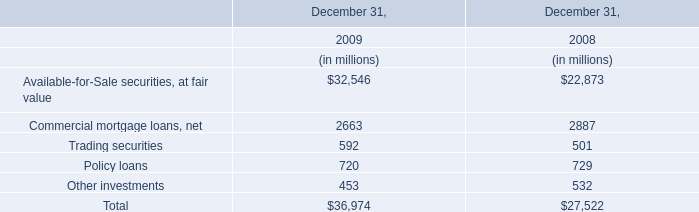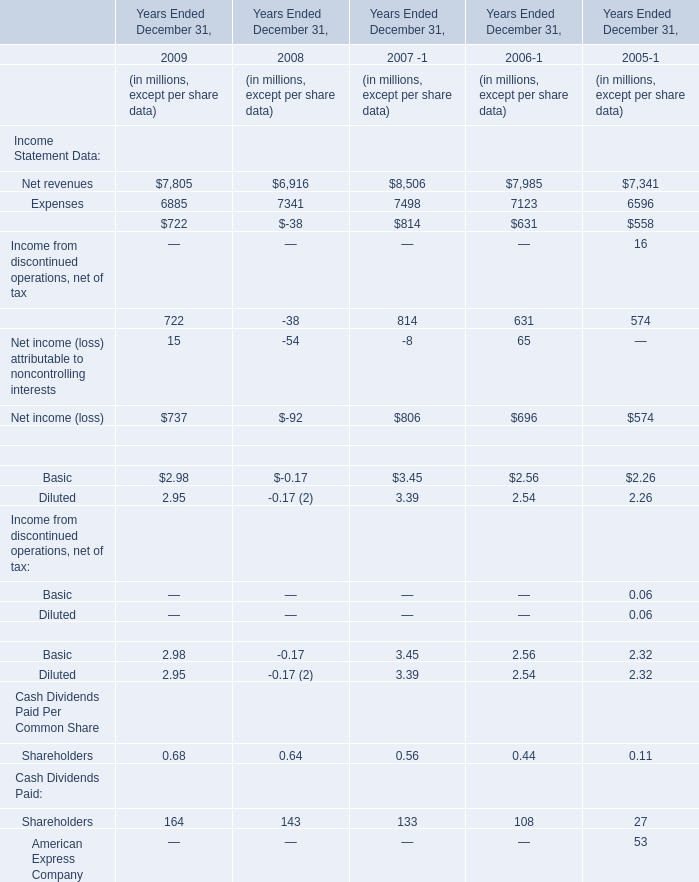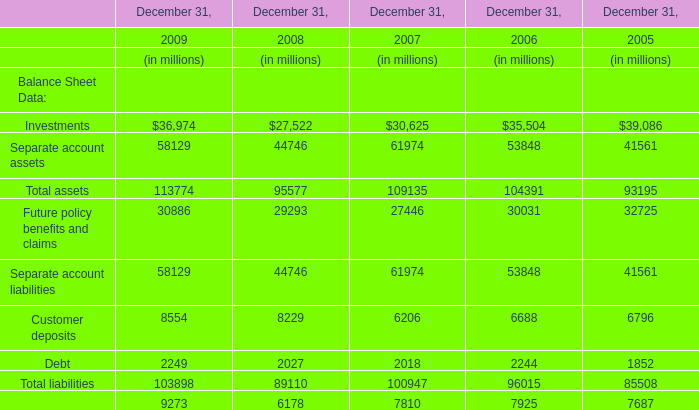In the year with largest amount of Total assets, what's the sum of Balance Sheet Data? (in million) 
Computations: ((((((((36974 + 58129) + 113774) + 30886) + 58129) + 8554) + 2249) + 103898) + 9273)
Answer: 421866.0. 